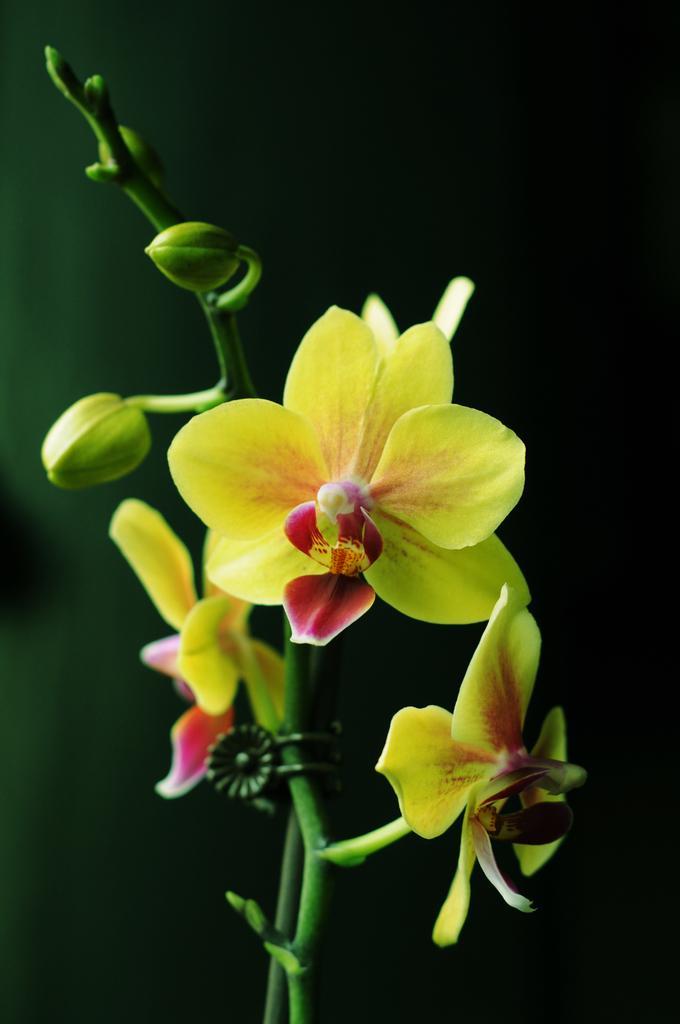How would you summarize this image in a sentence or two? In this image I can see the flowers to the plants. The flowers are in yellow and red color and there is a black background. 